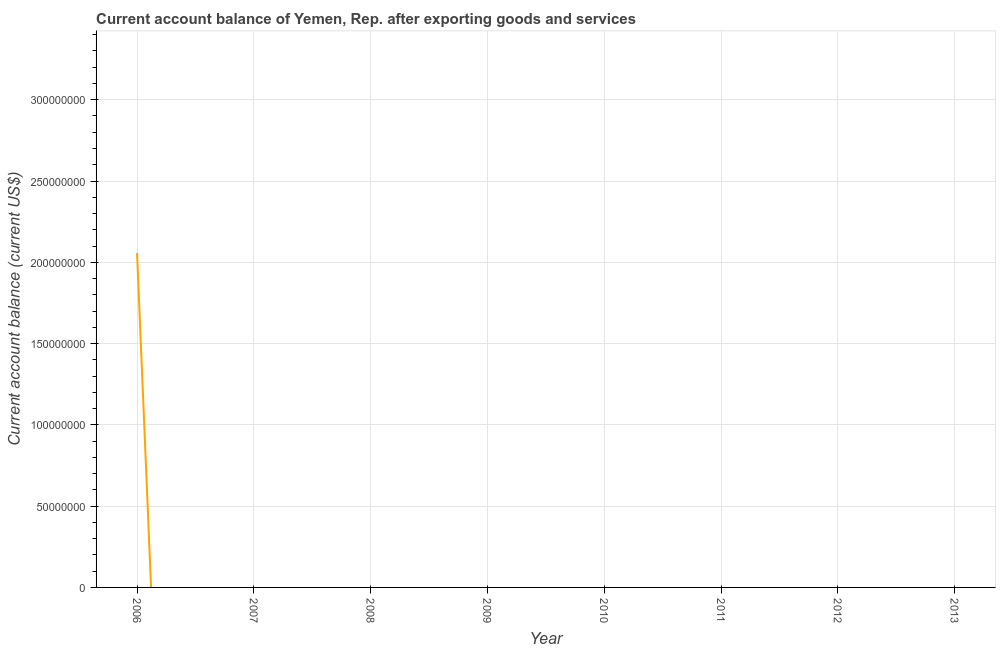What is the current account balance in 2009?
Make the answer very short. 0. Across all years, what is the maximum current account balance?
Your answer should be compact. 2.06e+08. Across all years, what is the minimum current account balance?
Ensure brevity in your answer.  0. In which year was the current account balance maximum?
Your answer should be very brief. 2006. What is the sum of the current account balance?
Give a very brief answer. 2.06e+08. What is the average current account balance per year?
Provide a short and direct response. 2.57e+07. In how many years, is the current account balance greater than 190000000 US$?
Ensure brevity in your answer.  1. What is the difference between the highest and the lowest current account balance?
Keep it short and to the point. 2.06e+08. In how many years, is the current account balance greater than the average current account balance taken over all years?
Your answer should be very brief. 1. Does the current account balance monotonically increase over the years?
Keep it short and to the point. No. How many lines are there?
Your response must be concise. 1. What is the difference between two consecutive major ticks on the Y-axis?
Offer a terse response. 5.00e+07. Does the graph contain any zero values?
Ensure brevity in your answer.  Yes. Does the graph contain grids?
Provide a short and direct response. Yes. What is the title of the graph?
Give a very brief answer. Current account balance of Yemen, Rep. after exporting goods and services. What is the label or title of the Y-axis?
Provide a short and direct response. Current account balance (current US$). What is the Current account balance (current US$) in 2006?
Provide a short and direct response. 2.06e+08. What is the Current account balance (current US$) in 2008?
Make the answer very short. 0. What is the Current account balance (current US$) in 2012?
Provide a succinct answer. 0. 